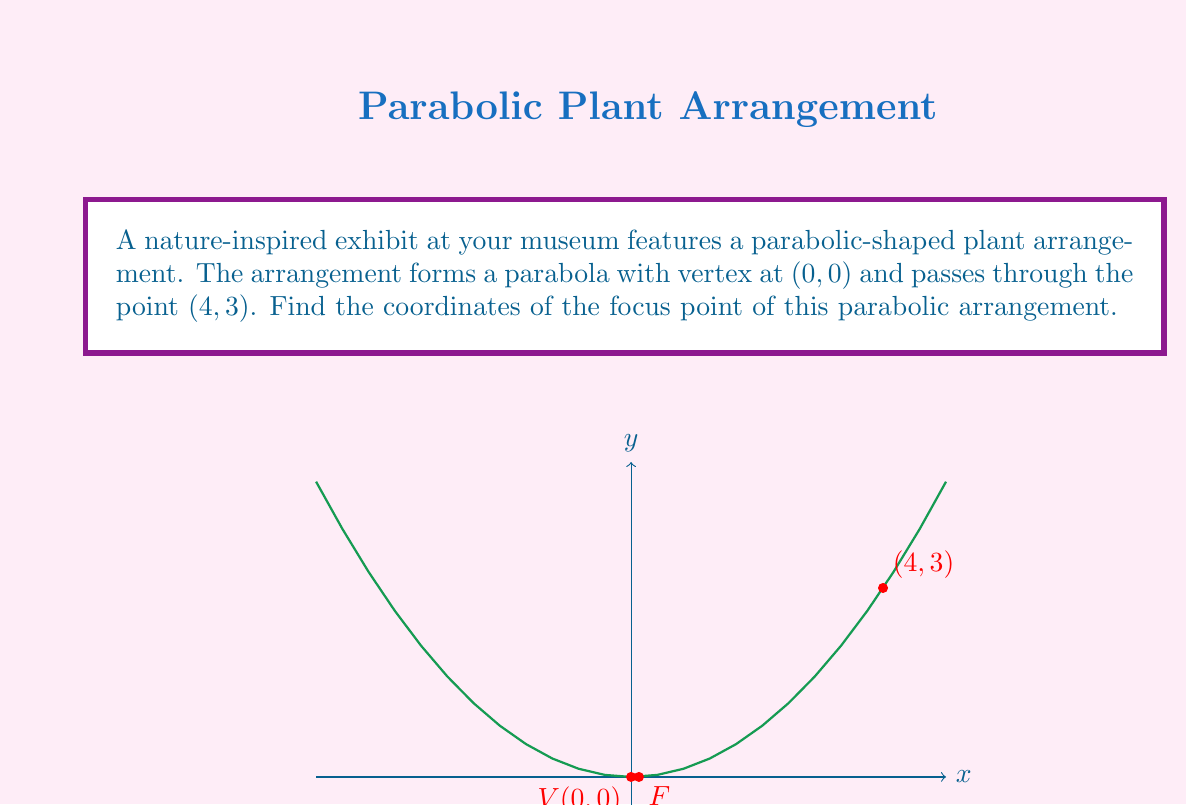Help me with this question. Let's approach this step-by-step:

1) The general equation of a parabola with vertex at (0, 0) is:
   $$ y = ax^2 $$
   where $a$ is a constant that determines the shape of the parabola.

2) We know that the parabola passes through the point (4, 3). Let's use this to find $a$:
   $$ 3 = a(4^2) $$
   $$ 3 = 16a $$
   $$ a = \frac{3}{16} $$

3) So, the equation of our parabola is:
   $$ y = \frac{3}{16}x^2 $$

4) For a parabola with equation $y = ax^2$, the focus point is located at $(0, \frac{1}{4a})$.

5) Substituting our value of $a$:
   $$ \text{Focus} = (0, \frac{1}{4(\frac{3}{16})}) $$
   $$ = (0, \frac{16}{12}) $$
   $$ = (0, \frac{4}{3}) $$
   $$ = (0, \frac{1}{8}) $$

Therefore, the focus point of the parabolic arrangement is at $(0, \frac{1}{8})$.
Answer: $(0, \frac{1}{8})$ 